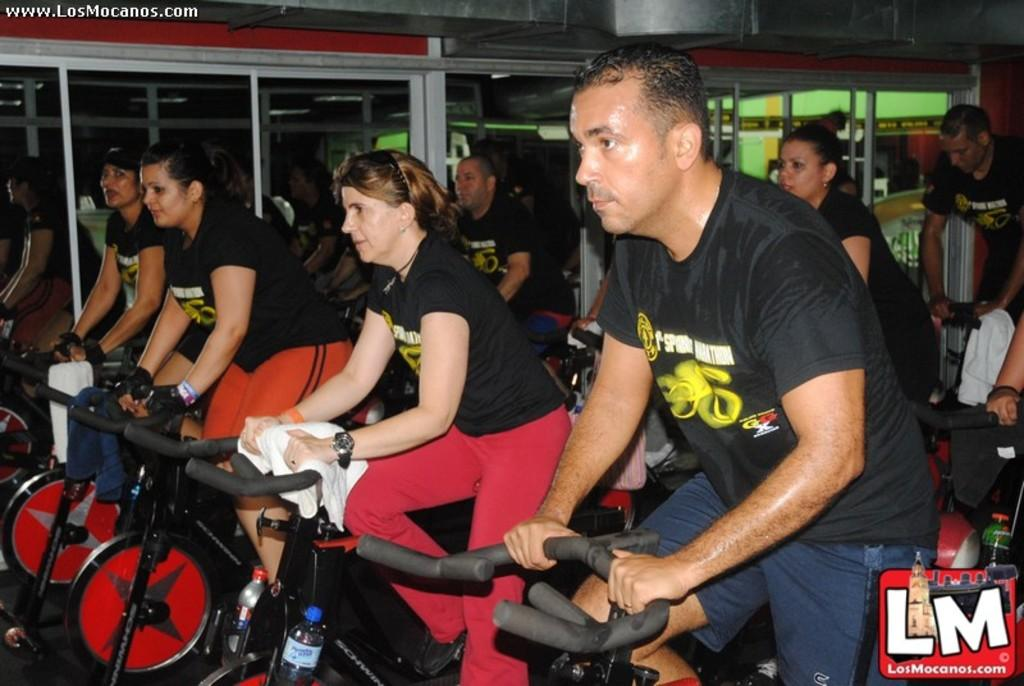What are the people in the image doing? The people in the image are riding bicycles. What else can be seen in the image besides the people riding bicycles? There are bottles visible in the image. How can you describe the clothing of the people in the image? The people are wearing different color dresses. What architectural feature can be seen in the background of the image? There are glass doors in the background of the image. What is the tendency of the heat in the image? There is no mention of heat in the image, so it is not possible to determine any tendency. 